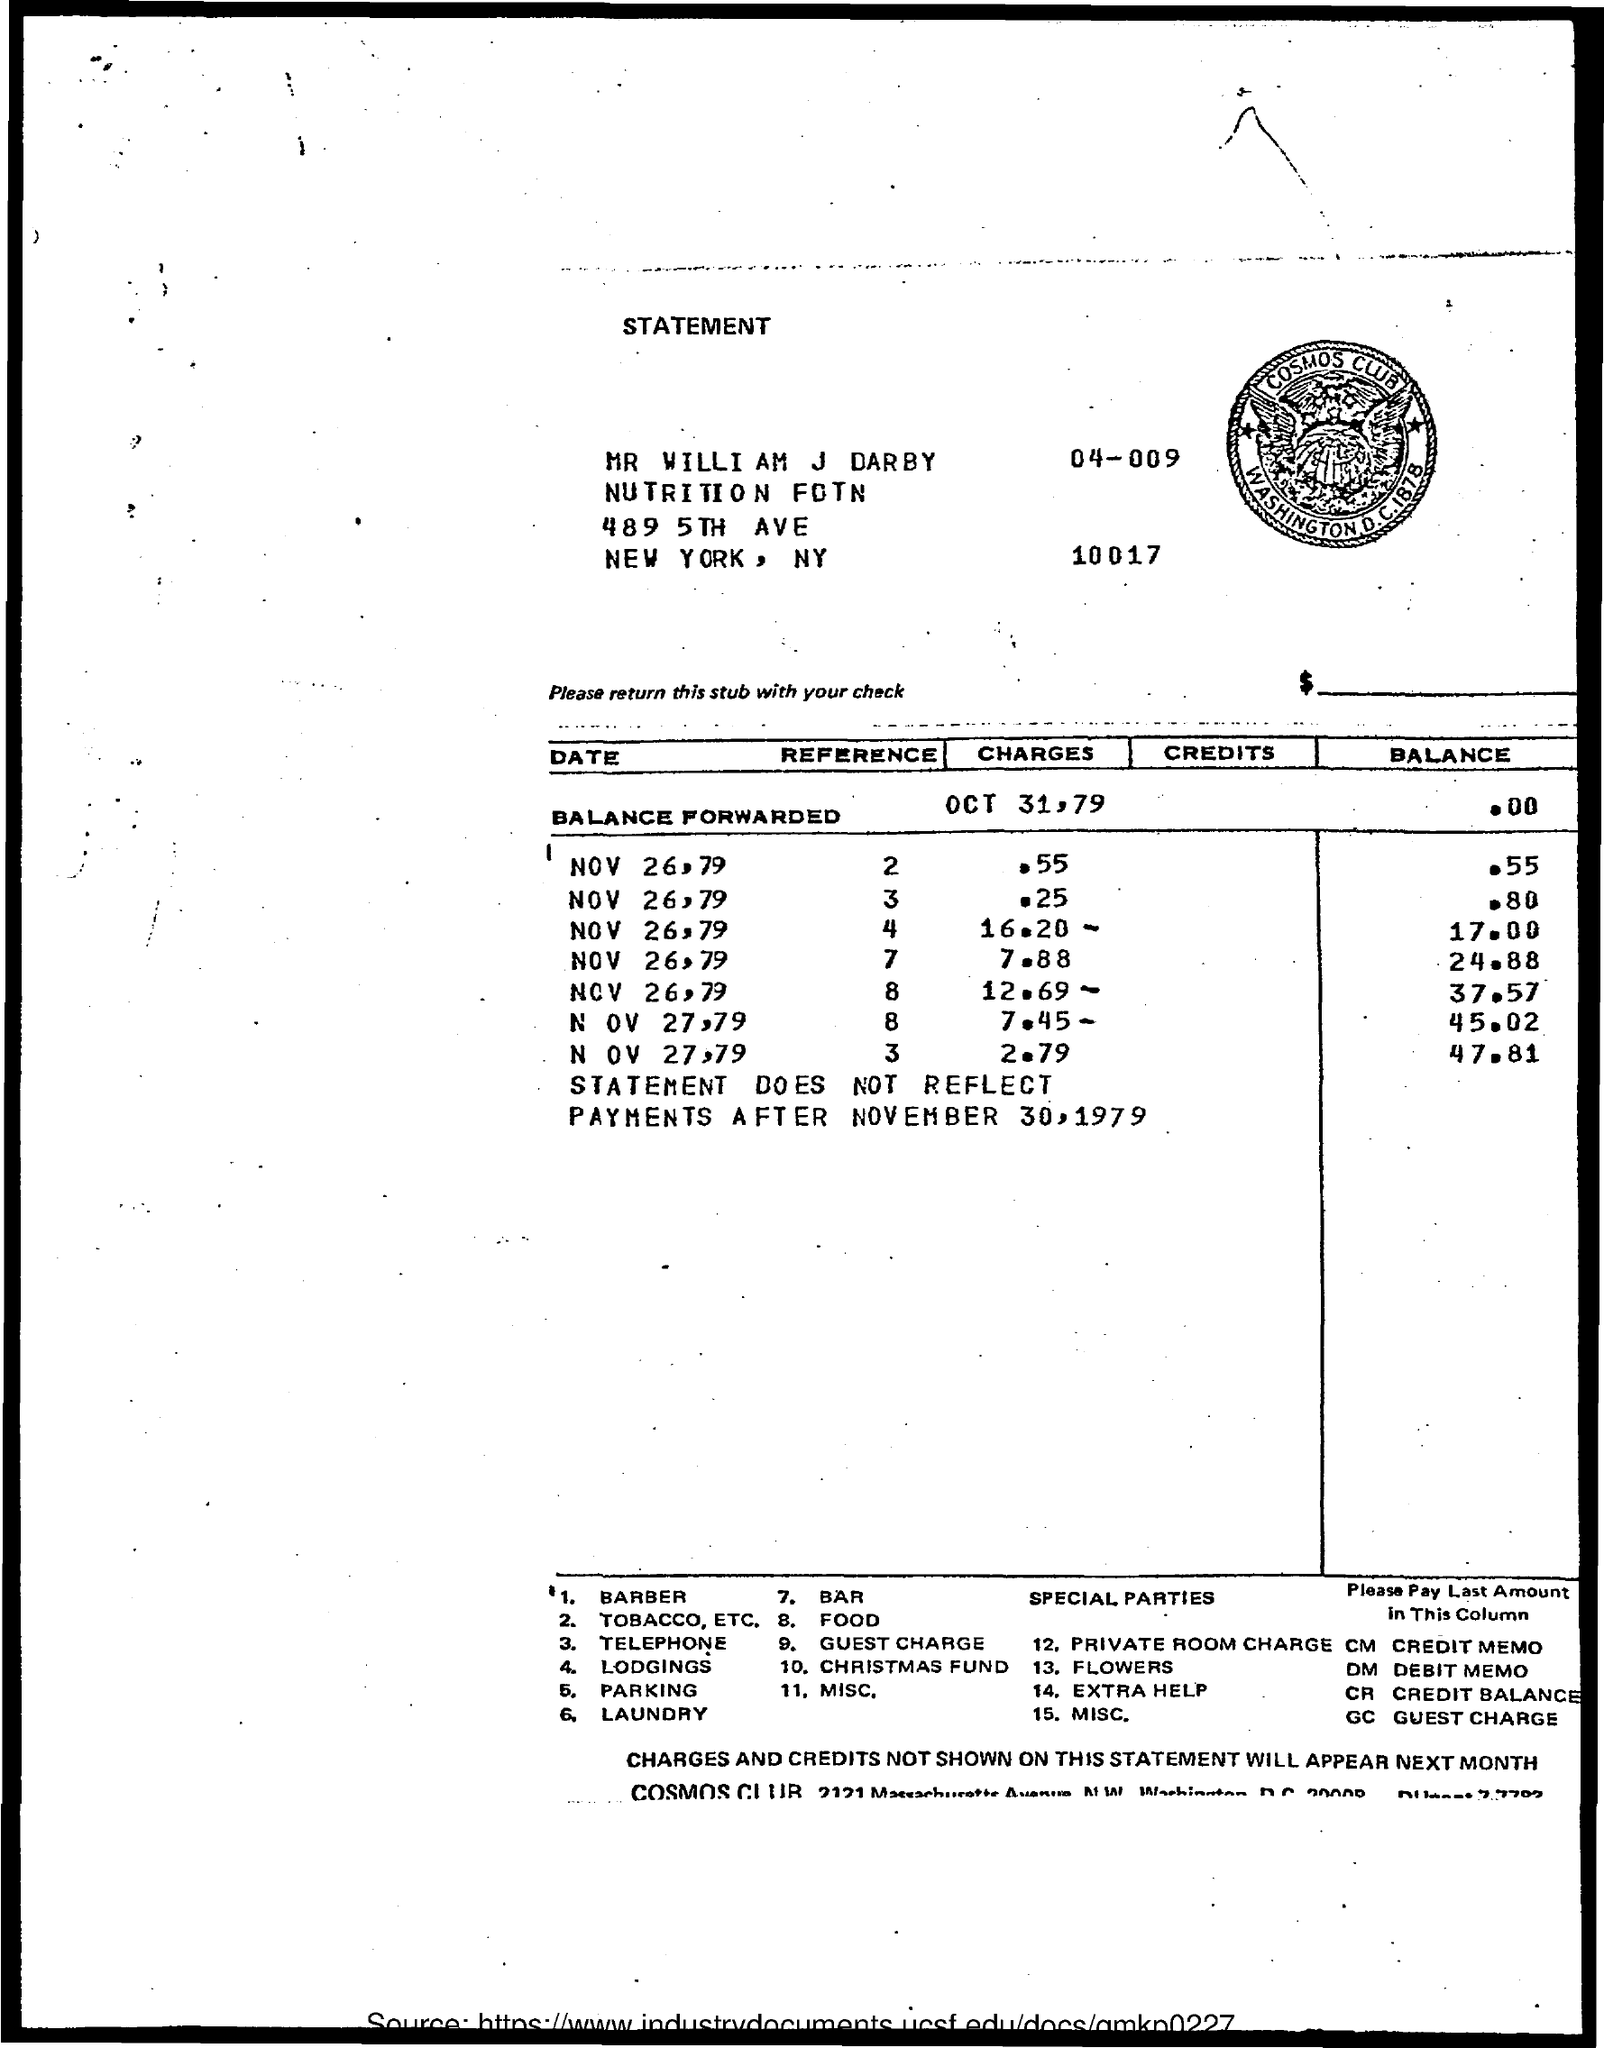What is the name of the person given in the statement?
Ensure brevity in your answer.  MR WILLIAM J DARBY. 